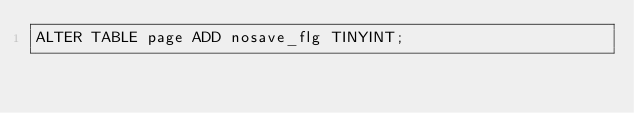Convert code to text. <code><loc_0><loc_0><loc_500><loc_500><_SQL_>ALTER TABLE page ADD nosave_flg TINYINT;
</code> 